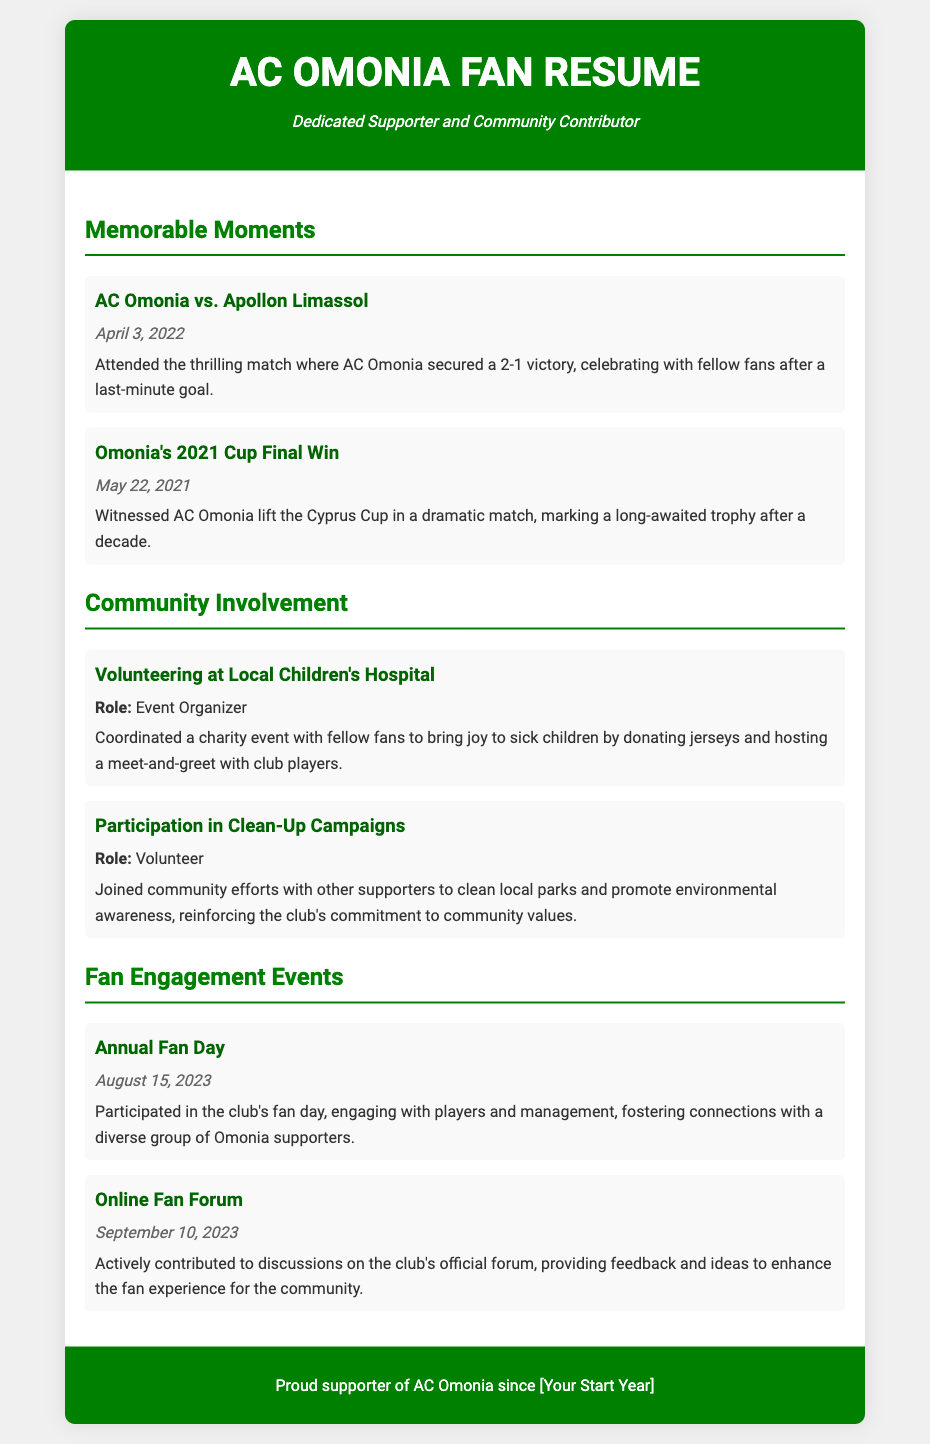What was the score in the match against Apollon Limassol? The score in the match mentioned is 2-1.
Answer: 2-1 When did AC Omonia win the Cyprus Cup? The date when AC Omonia won the Cyprus Cup is noted as May 22, 2021.
Answer: May 22, 2021 What role did the supporter have at the local children's hospital event? The role was that of an Event Organizer.
Answer: Event Organizer What community activity did the supporter participate in? The supporter joined clean-up campaigns.
Answer: Clean-Up Campaigns What event took place on August 15, 2023? The annual fan day occurred on this date.
Answer: Annual Fan Day What was discussed in the online fan forum? The discussions involved feedback and ideas to enhance fan experience.
Answer: Feedback and ideas How long had the supporter been affiliated with AC Omonia? The specific year is not mentioned; it's indicated as "Your Start Year."
Answer: Your Start Year What was given to sick children during the hospital event? Jerseys were donated to sick children.
Answer: Jerseys 